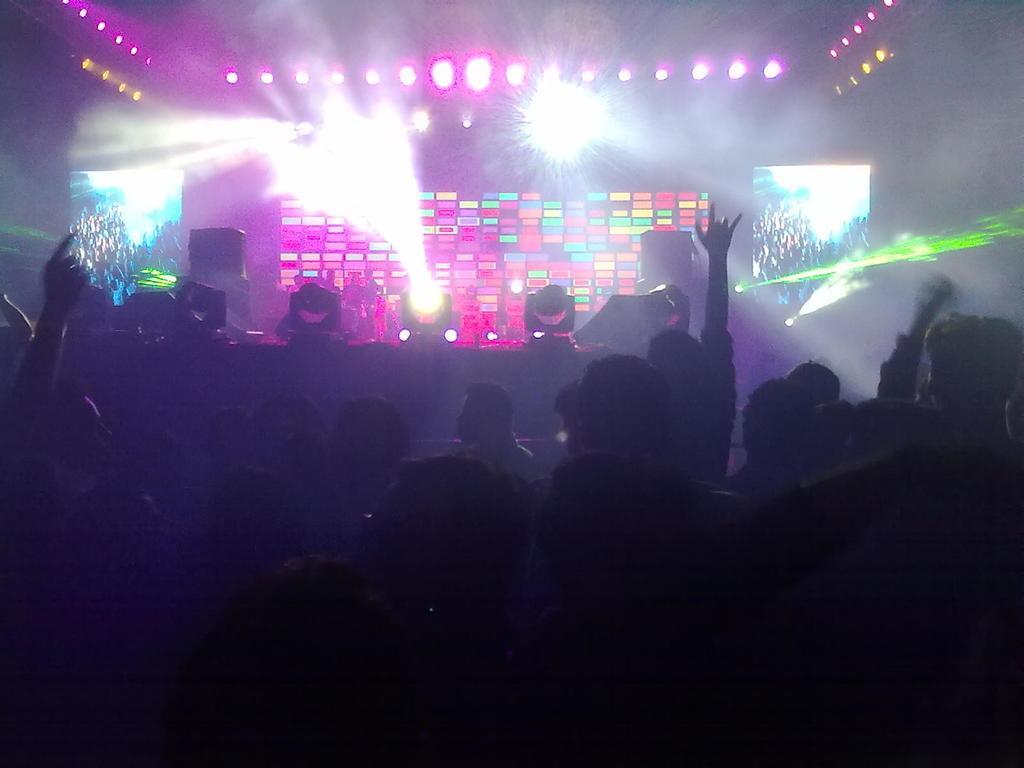How would you summarize this image in a sentence or two? In this image in the middle there is a disco light and from left to right, there are people who are enjoying. 